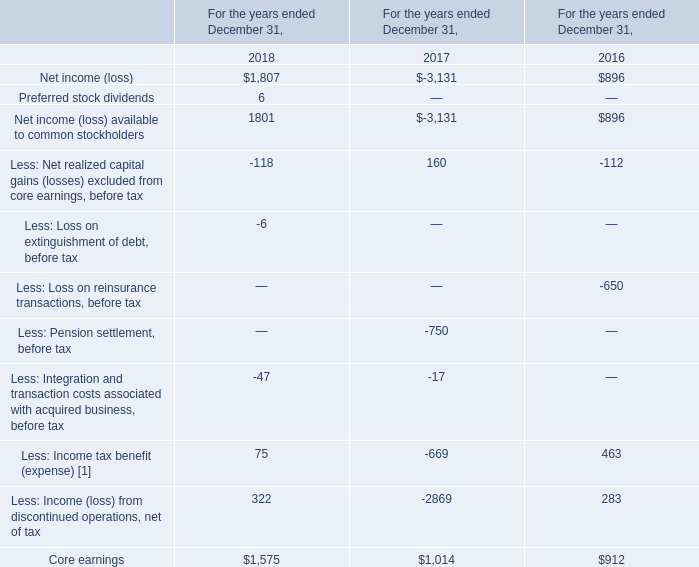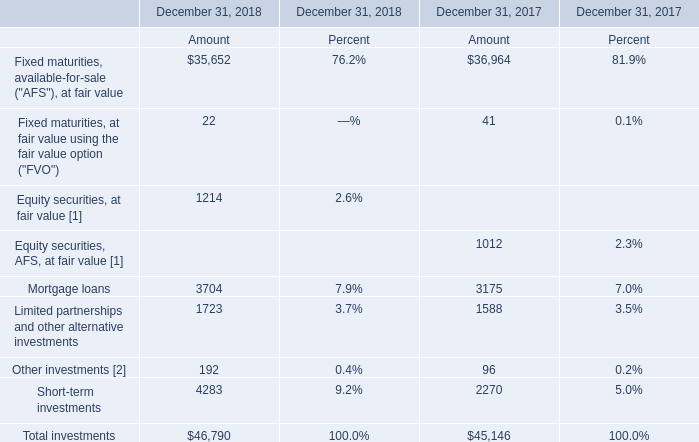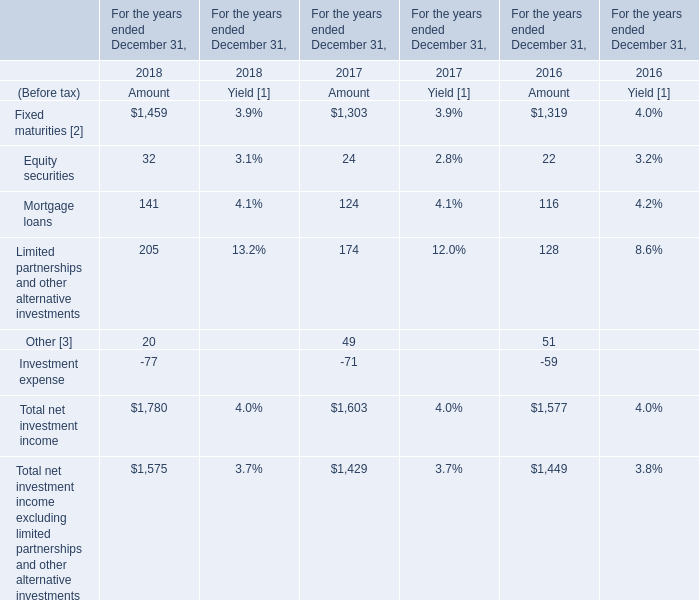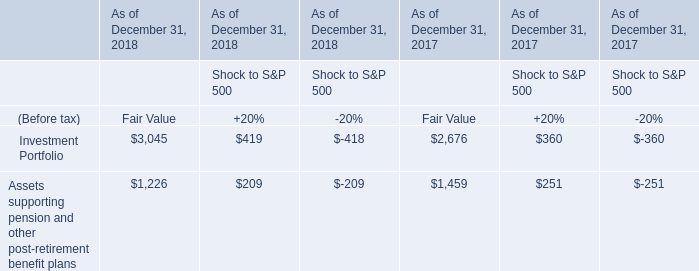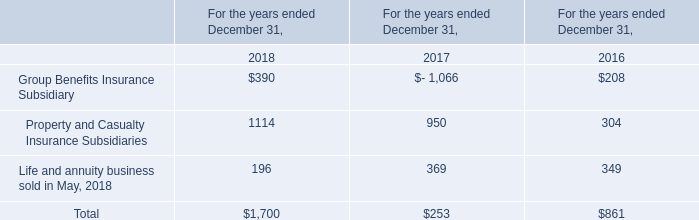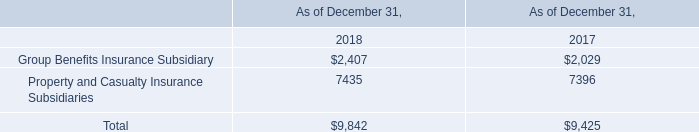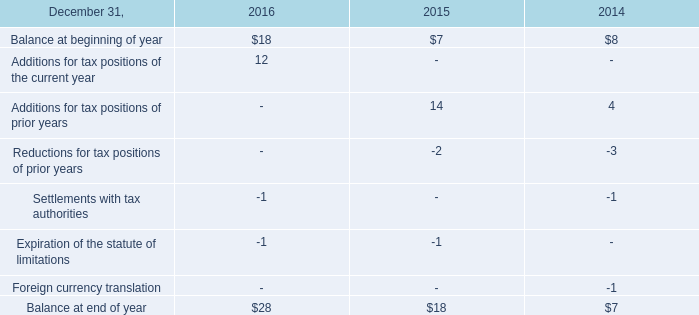Which element makes up more than 5% of the total in 2017? 
Answer: Fixed maturities, available-for-sale ("AFS"), at fair value, Mortgage loans, Short-term investments. 